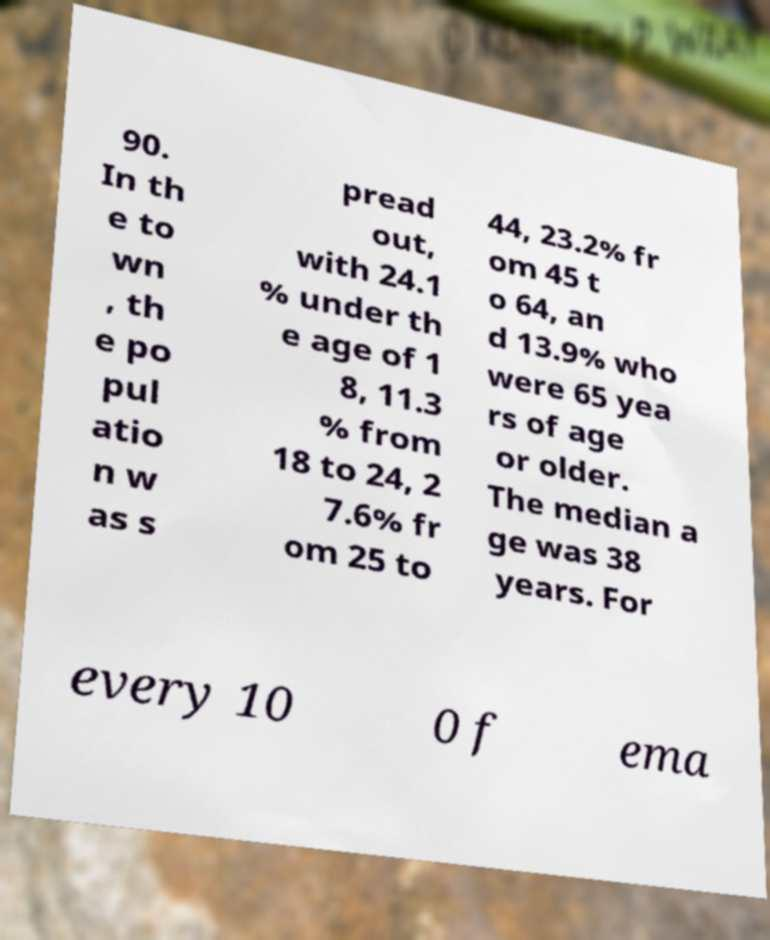For documentation purposes, I need the text within this image transcribed. Could you provide that? 90. In th e to wn , th e po pul atio n w as s pread out, with 24.1 % under th e age of 1 8, 11.3 % from 18 to 24, 2 7.6% fr om 25 to 44, 23.2% fr om 45 t o 64, an d 13.9% who were 65 yea rs of age or older. The median a ge was 38 years. For every 10 0 f ema 